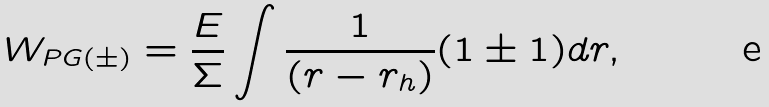Convert formula to latex. <formula><loc_0><loc_0><loc_500><loc_500>W _ { P G ( \pm ) } = \frac { E } { \Sigma } \int \frac { 1 } { ( r - r _ { h } ) } ( 1 \pm 1 ) d r ,</formula> 